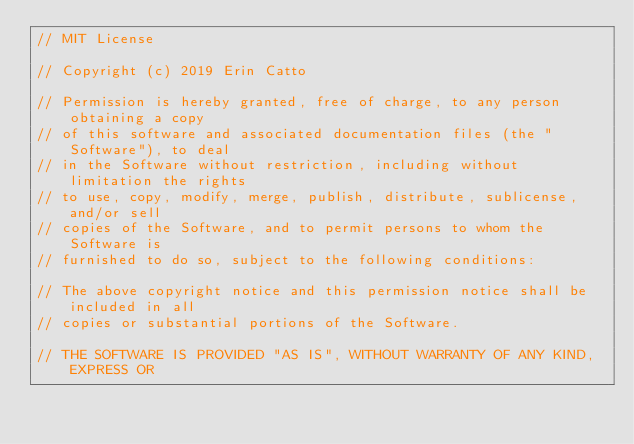<code> <loc_0><loc_0><loc_500><loc_500><_C++_>// MIT License

// Copyright (c) 2019 Erin Catto

// Permission is hereby granted, free of charge, to any person obtaining a copy
// of this software and associated documentation files (the "Software"), to deal
// in the Software without restriction, including without limitation the rights
// to use, copy, modify, merge, publish, distribute, sublicense, and/or sell
// copies of the Software, and to permit persons to whom the Software is
// furnished to do so, subject to the following conditions:

// The above copyright notice and this permission notice shall be included in all
// copies or substantial portions of the Software.

// THE SOFTWARE IS PROVIDED "AS IS", WITHOUT WARRANTY OF ANY KIND, EXPRESS OR</code> 